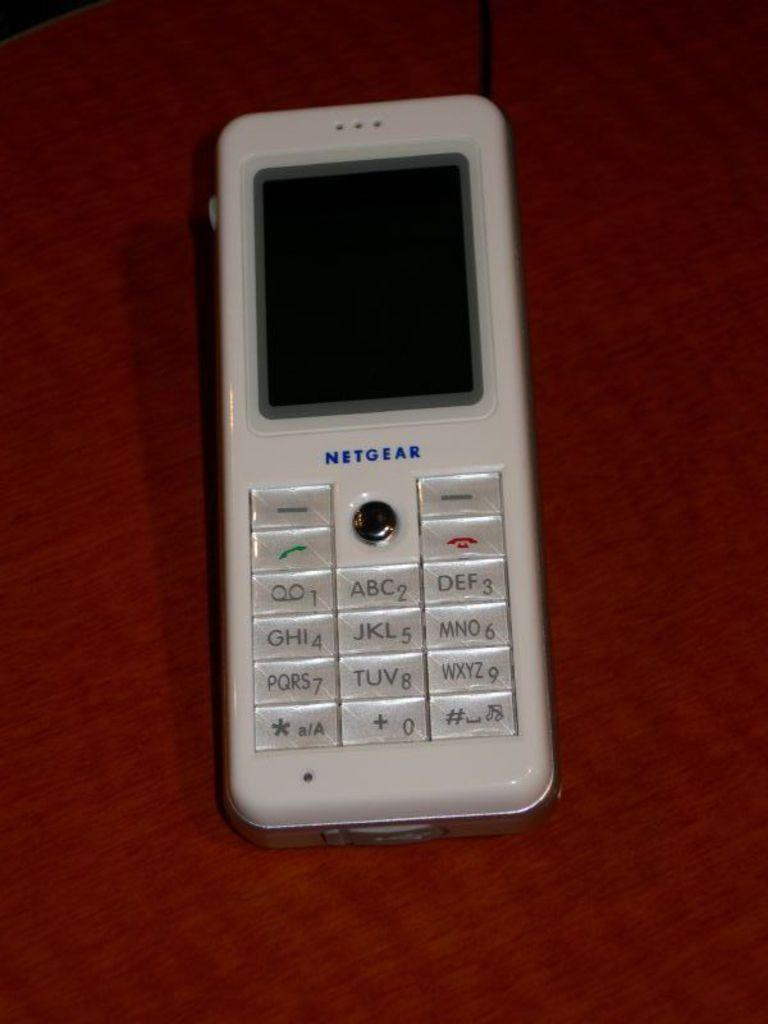<image>
Relay a brief, clear account of the picture shown. The old white phone sitting on the table is a Netgear phone. 